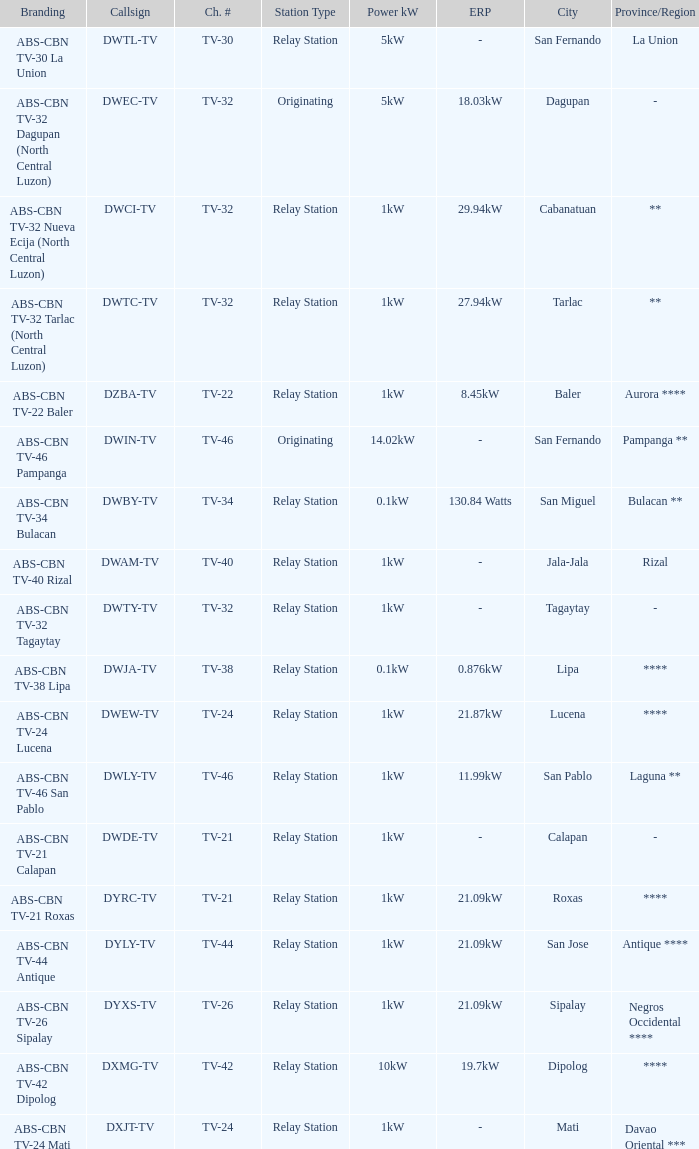What is the station type for the branding ABS-CBN TV-32 Tagaytay? Relay Station. 